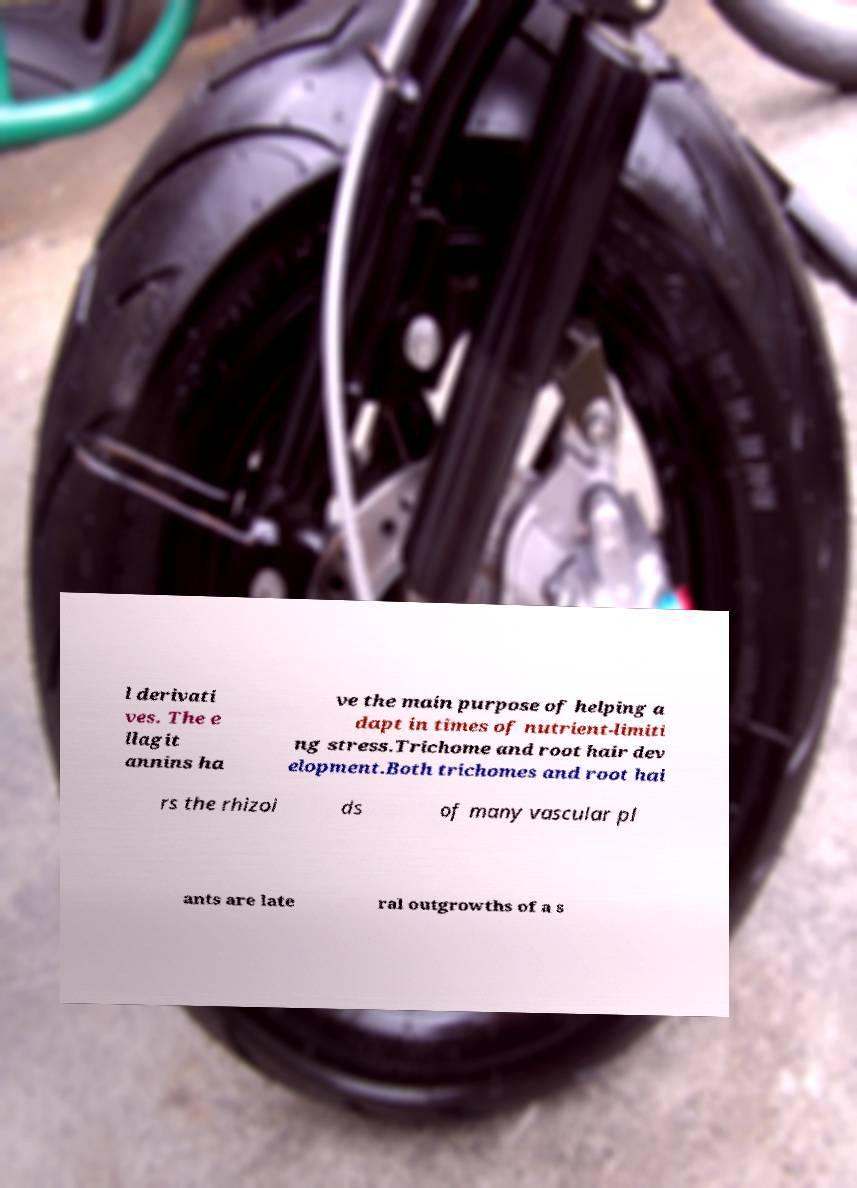There's text embedded in this image that I need extracted. Can you transcribe it verbatim? l derivati ves. The e llagit annins ha ve the main purpose of helping a dapt in times of nutrient-limiti ng stress.Trichome and root hair dev elopment.Both trichomes and root hai rs the rhizoi ds of many vascular pl ants are late ral outgrowths of a s 